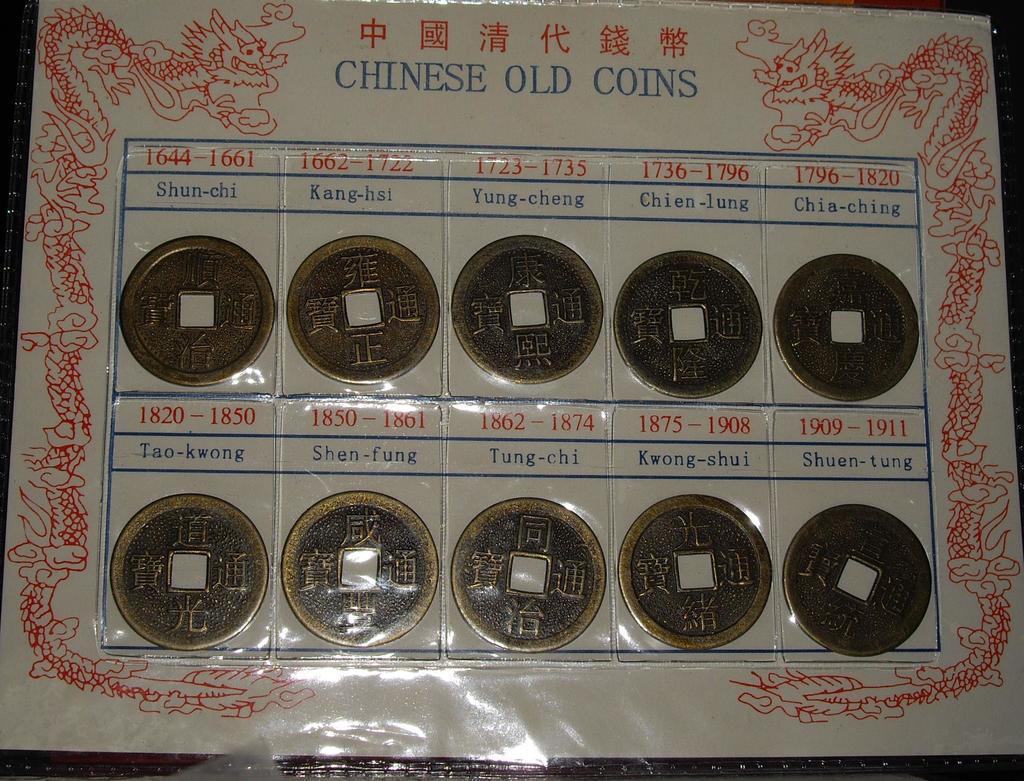<image>
Share a concise interpretation of the image provided. A collection of CHINESE OLD COINS from 1644 to 1911 are displayed in a plastic covered secure way. 